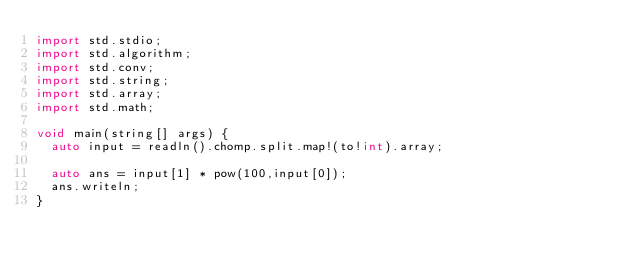Convert code to text. <code><loc_0><loc_0><loc_500><loc_500><_D_>import std.stdio;
import std.algorithm;
import std.conv;
import std.string;
import std.array;
import std.math;

void main(string[] args) {
  auto input = readln().chomp.split.map!(to!int).array;

  auto ans = input[1] * pow(100,input[0]);
  ans.writeln;
}</code> 